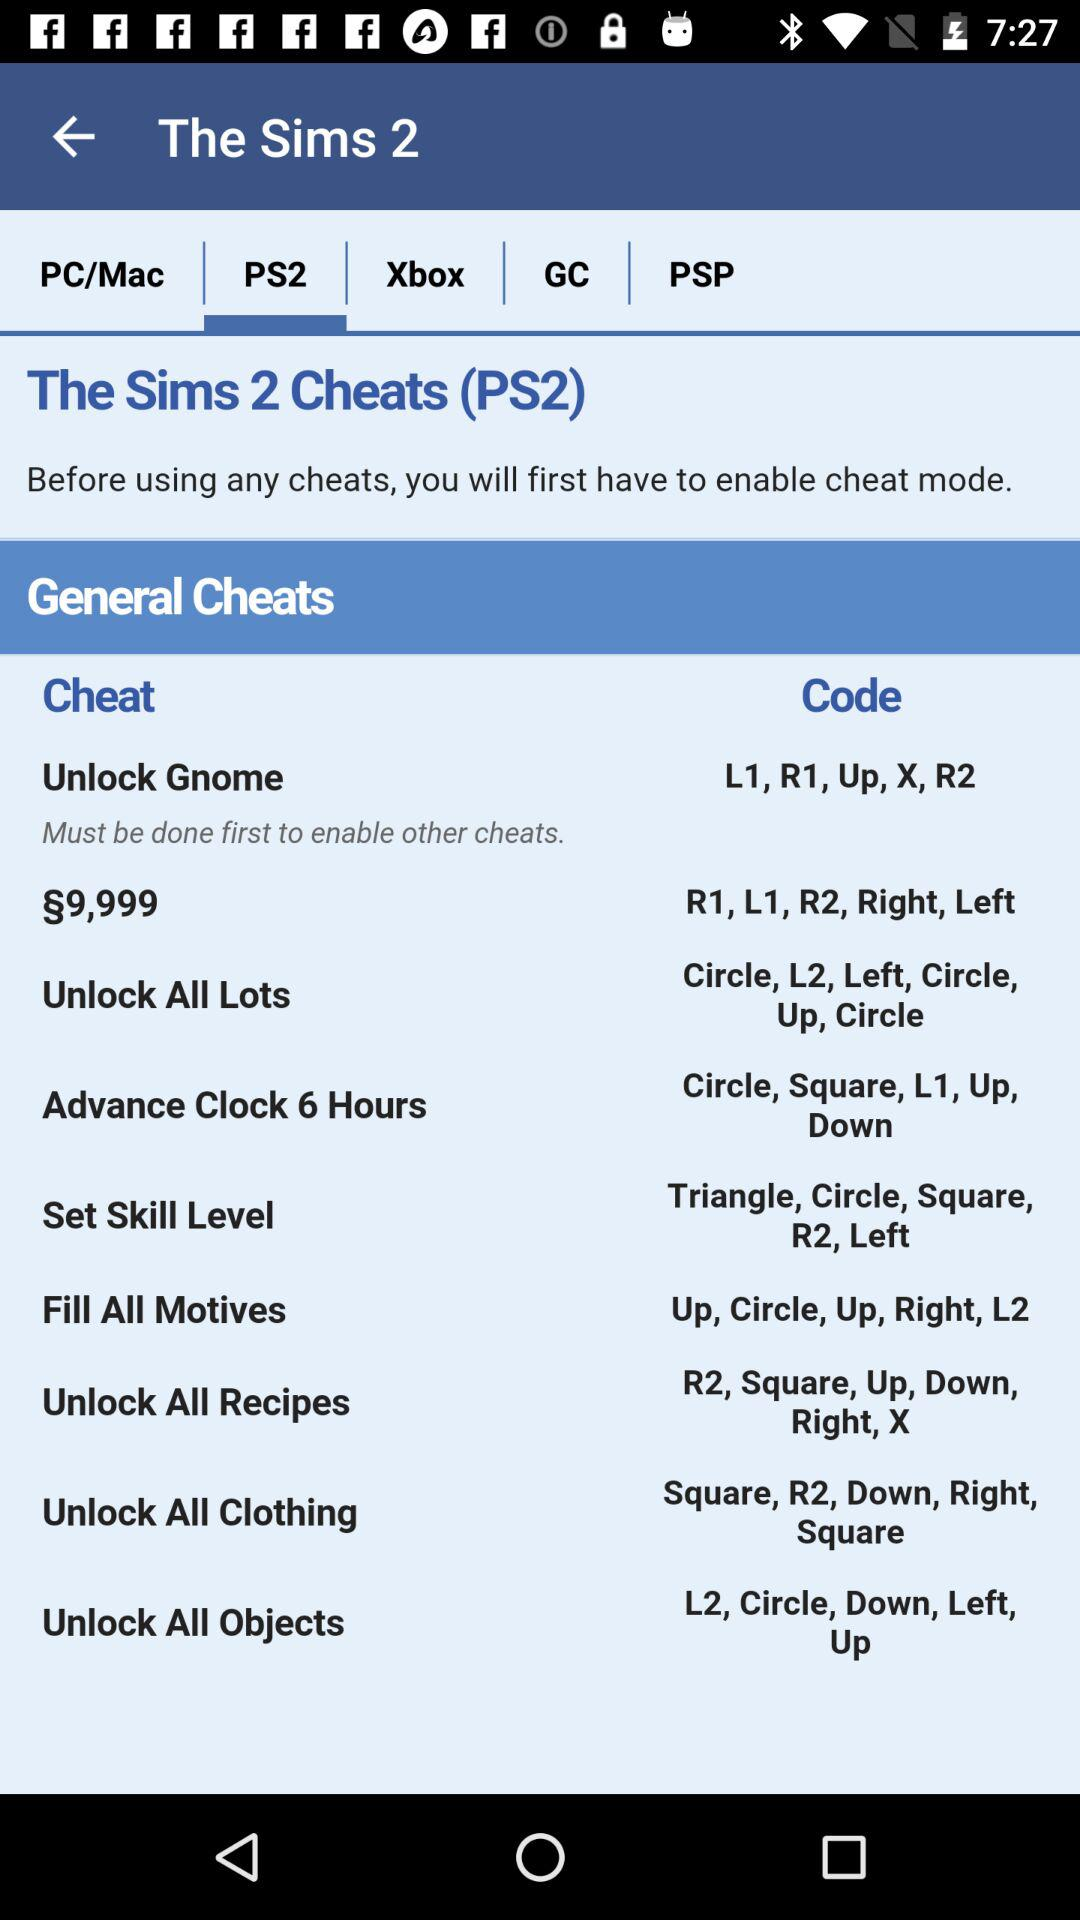What is the code for "Set Skill Level"? The code for "Set Skill Level" is "Triangle, Circle, Square, R2, Left". 